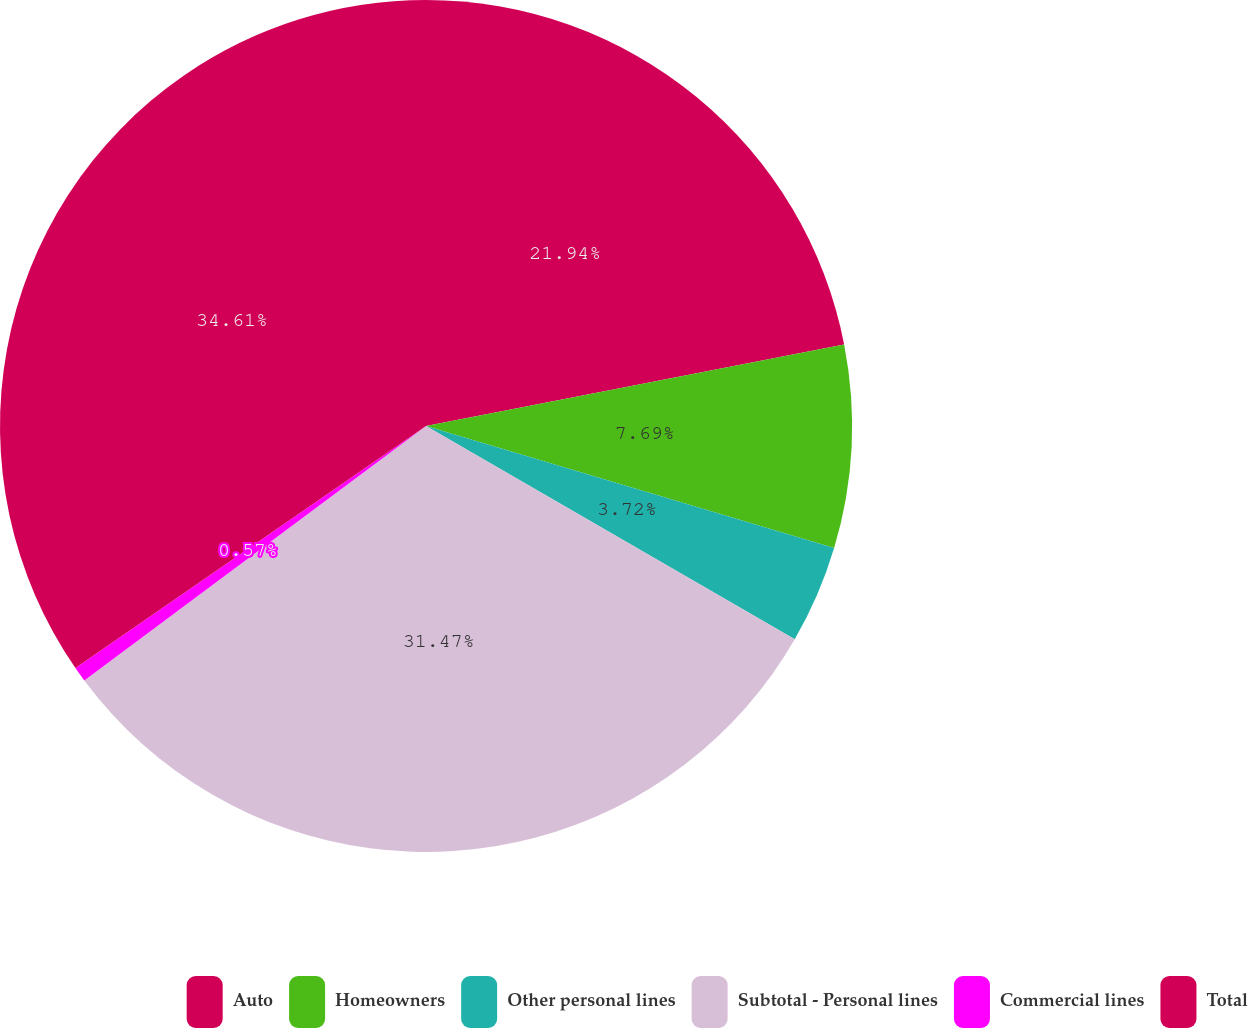<chart> <loc_0><loc_0><loc_500><loc_500><pie_chart><fcel>Auto<fcel>Homeowners<fcel>Other personal lines<fcel>Subtotal - Personal lines<fcel>Commercial lines<fcel>Total<nl><fcel>21.94%<fcel>7.69%<fcel>3.72%<fcel>31.47%<fcel>0.57%<fcel>34.62%<nl></chart> 